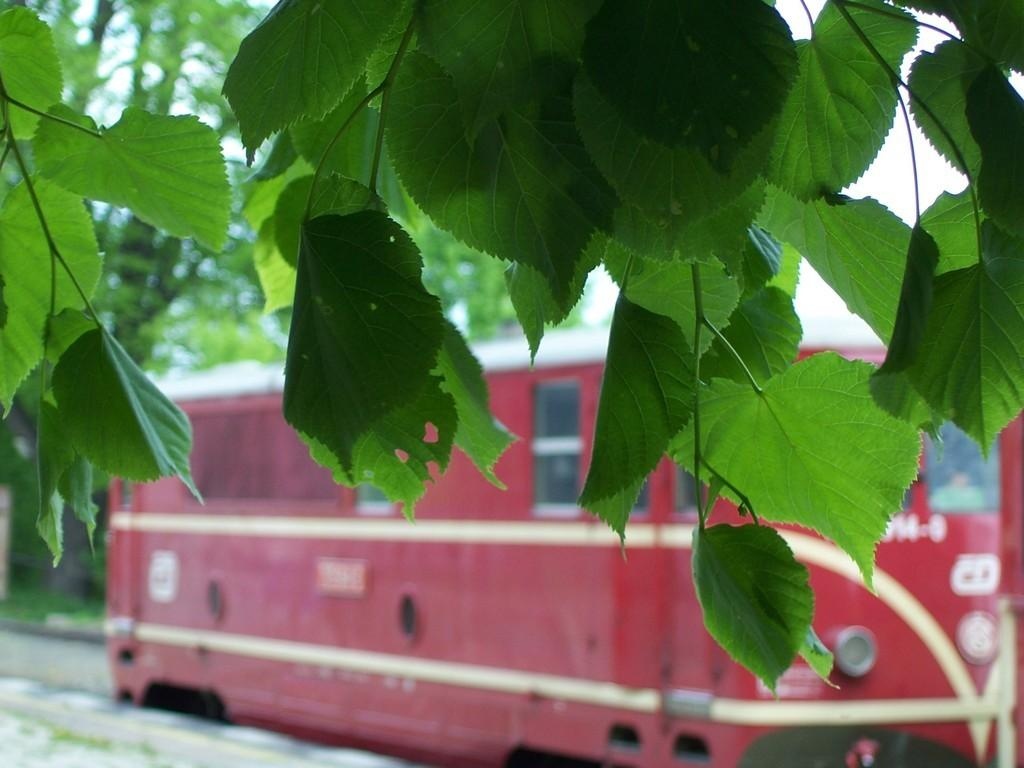What type of vegetation can be seen in the image? There are leaves and trees in the image. What mode of transportation is present in the image? There is a red color bus in the image. What part of the natural environment is visible in the image? The sky is visible in the image. How many bottles can be seen on the beds in the image? There are no bottles or beds present in the image. What is the starting point of the journey depicted in the image? The image does not depict a journey or a starting point. 